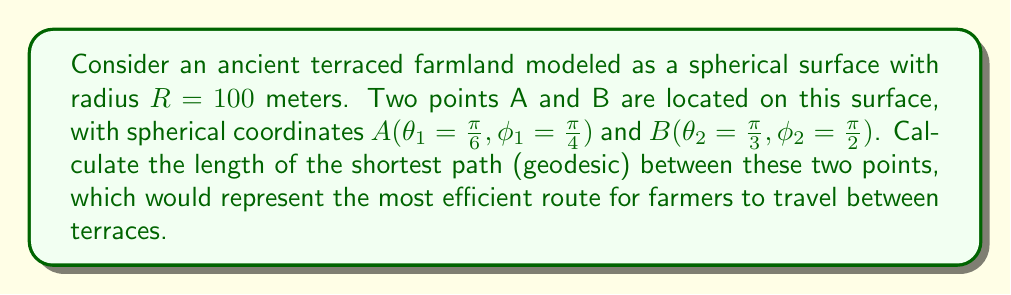Give your solution to this math problem. To find the shortest path between two points on a spherical surface, we need to calculate the great circle distance. This involves the following steps:

1) First, we use the spherical law of cosines to find the central angle $Δσ$ between the two points:

   $$\cos(Δσ) = \sin(θ_1)\sin(θ_2) + \cos(θ_1)\cos(θ_2)\cos(|φ_2 - φ_1|)$$

2) Substituting the given values:

   $$\cos(Δσ) = \sin(\frac{\pi}{6})\sin(\frac{\pi}{3}) + \cos(\frac{\pi}{6})\cos(\frac{\pi}{3})\cos(|\frac{\pi}{2} - \frac{\pi}{4}|)$$

3) Simplifying:

   $$\cos(Δσ) = \frac{1}{2} \cdot \frac{\sqrt{3}}{2} + \frac{\sqrt{3}}{2} \cdot \frac{1}{2} \cdot \cos(\frac{\pi}{4})$$
   
   $$= \frac{\sqrt{3}}{4} + \frac{\sqrt{3}}{4} \cdot \frac{\sqrt{2}}{2}$$
   
   $$= \frac{\sqrt{3}}{4}(1 + \frac{\sqrt{2}}{2})$$

4) Taking the arccos of both sides:

   $$Δσ = \arccos(\frac{\sqrt{3}}{4}(1 + \frac{\sqrt{2}}{2}))$$

5) The length of the geodesic $d$ is then given by:

   $$d = R \cdot Δσ$$

6) Substituting $R = 100$ meters:

   $$d = 100 \cdot \arccos(\frac{\sqrt{3}}{4}(1 + \frac{\sqrt{2}}{2}))$$

This gives us the shortest path between the two points on the spherical terraced farmland.
Answer: $100 \cdot \arccos(\frac{\sqrt{3}}{4}(1 + \frac{\sqrt{2}}{2}))$ meters 